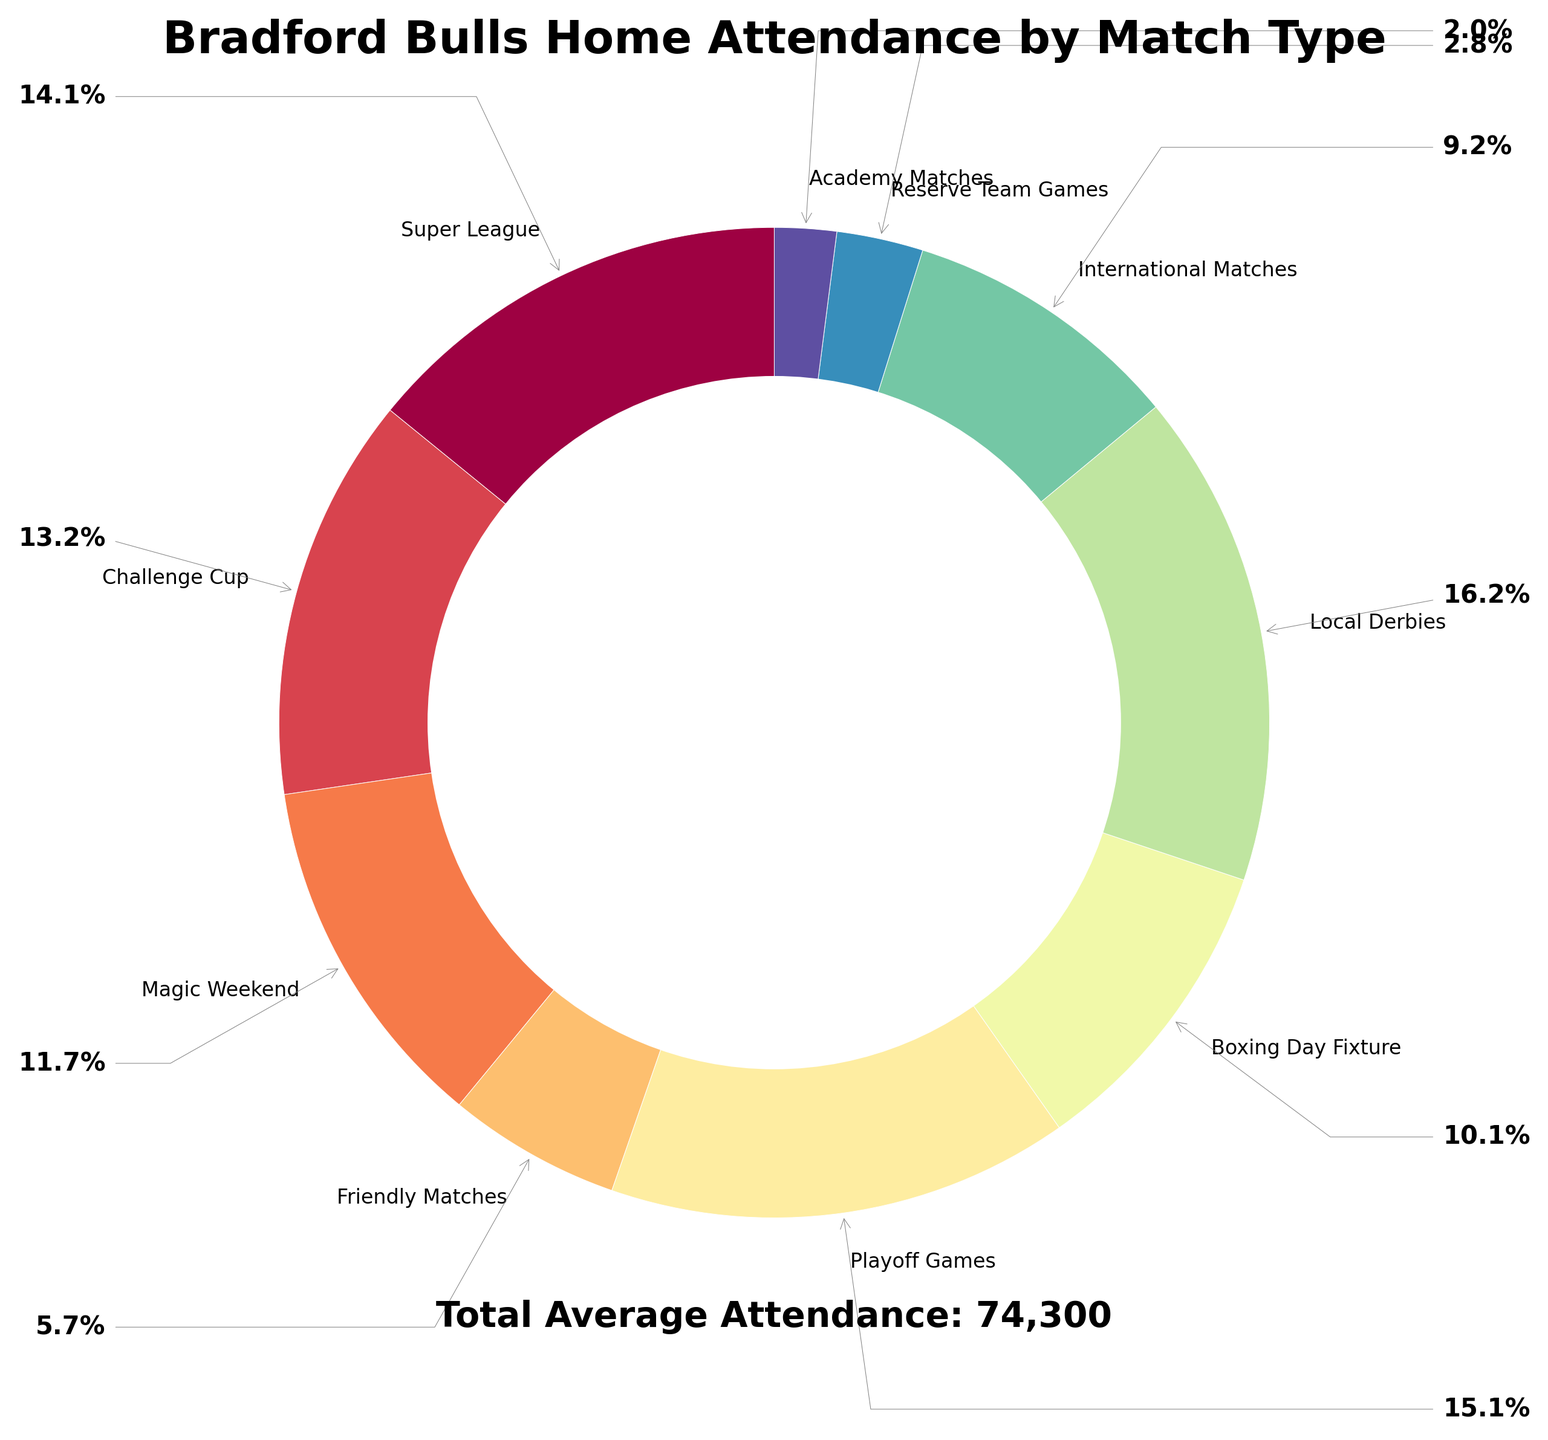What is the match type with the highest average attendance? The match type with the highest average attendance is found by looking at the largest slice of the pie chart. Local Derbies have the largest slice.
Answer: Local Derbies How much higher is the average attendance for Playoff games compared to Magic Weekend? Find the average attendance for Playoff Games (11,200) and for Magic Weekend (8,700). Calculate the difference: 11,200 - 8,700 = 2,500.
Answer: 2,500 What is the combined average attendance for Friendly Matches and Reserve Team Games? Sum the average attendance for Friendly Matches (4,200) and Reserve Team Games (2,100): 4,200 + 2,100 = 6,300.
Answer: 6,300 Which match type has the smallest average attendance and what is the percentage of the total average attendance it represents? Look for the smallest slice on the pie chart, which is Academy Matches (1,500). Calculate the percentage it represents relative to the total average attendance (1,500 / 78,800 * 100 ≈ 1.9%).
Answer: Academy Matches, 1.9% If you combine the average attendance of Super League and Challenge Cup, would it be greater than the combined average attendance of Local Derbies and Boxing Day Fixture? Sum Super League (10,500) and Challenge Cup (9,800) to get 20,300. Sum Local Derbies (12,000) and Boxing Day Fixture (7,500) to get 19,500. Compare the two sums: 20,300 > 19,500.
Answer: Yes Between International Matches and Boxing Day Fixture, which one has a lower contribution to the total average attendance and by how much? Find the average attendance for International Matches (6,800) and Boxing Day Fixture (7,500). Subtract to find the difference: 7,500 - 6,800 = 700.
Answer: International Matches, by 700 What are the match types with an average attendance above 10,000? Identify the slices with values above 10,000. They are Super League (10,500), Playoff Games (11,200), and Local Derbies (12,000).
Answer: Super League, Playoff Games, Local Derbies What is the percentage of total average attendance for the Boxing Day Fixture? The average attendance for Boxing Day Fixture is 7,500. Calculate its percentage of the total: 7,500 / 78,800 * 100 ≈ 9.5%.
Answer: 9.5% How does the average attendance for Reserve Team Games compare to Academy Matches? Find the average attendance for both categories (Reserve Team Games 2,100 and Academy Matches 1,500). Compare them: 2,100 > 1,500.
Answer: Reserve Team Games have higher attendance By how much does the average attendance for Local Derbies exceed the average of Friendly Matches and Boxing Day Fixture combined? Calculate the average attendance for Friendly Matches (4,200) and Boxing Day Fixture (7,500), then sum them up: 4,200 + 7,500 = 11,700. Local Derbies (12,000) exceed this combined number by: 12,000 - 11,700 = 300.
Answer: 300 